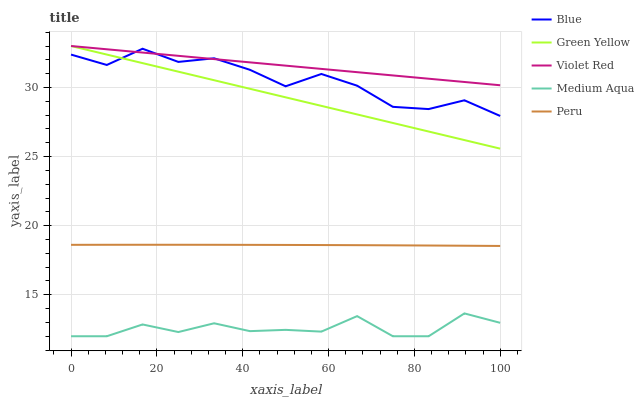Does Medium Aqua have the minimum area under the curve?
Answer yes or no. Yes. Does Violet Red have the maximum area under the curve?
Answer yes or no. Yes. Does Green Yellow have the minimum area under the curve?
Answer yes or no. No. Does Green Yellow have the maximum area under the curve?
Answer yes or no. No. Is Green Yellow the smoothest?
Answer yes or no. Yes. Is Blue the roughest?
Answer yes or no. Yes. Is Violet Red the smoothest?
Answer yes or no. No. Is Violet Red the roughest?
Answer yes or no. No. Does Green Yellow have the lowest value?
Answer yes or no. No. Does Green Yellow have the highest value?
Answer yes or no. Yes. Does Medium Aqua have the highest value?
Answer yes or no. No. Is Medium Aqua less than Peru?
Answer yes or no. Yes. Is Blue greater than Peru?
Answer yes or no. Yes. Does Violet Red intersect Blue?
Answer yes or no. Yes. Is Violet Red less than Blue?
Answer yes or no. No. Is Violet Red greater than Blue?
Answer yes or no. No. Does Medium Aqua intersect Peru?
Answer yes or no. No. 